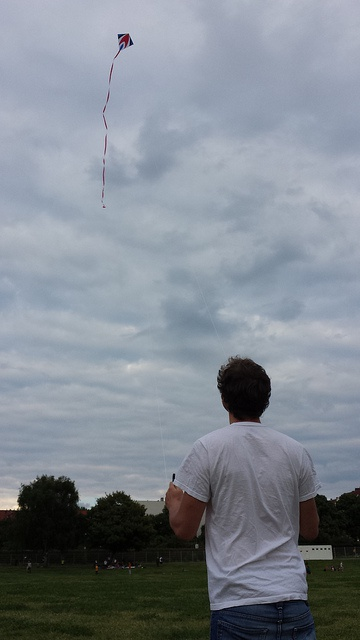Describe the objects in this image and their specific colors. I can see people in darkgray, gray, and black tones and kite in darkgray, purple, and maroon tones in this image. 